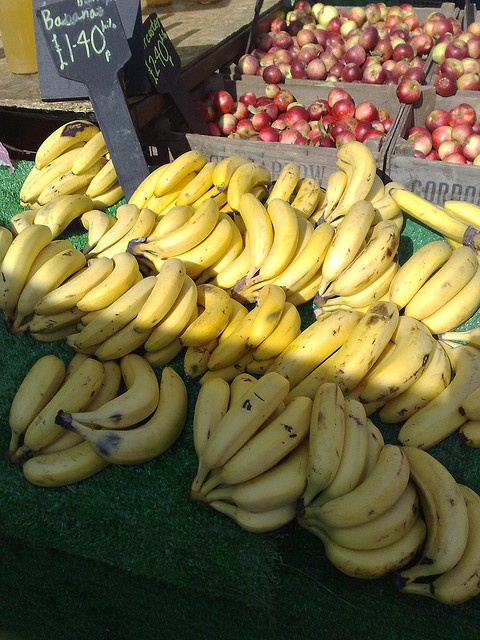Describe the objects in this image and their specific colors. I can see banana in olive, khaki, and black tones, banana in olive and black tones, banana in olive, khaki, and tan tones, banana in olive and black tones, and apple in olive, brown, maroon, and tan tones in this image. 